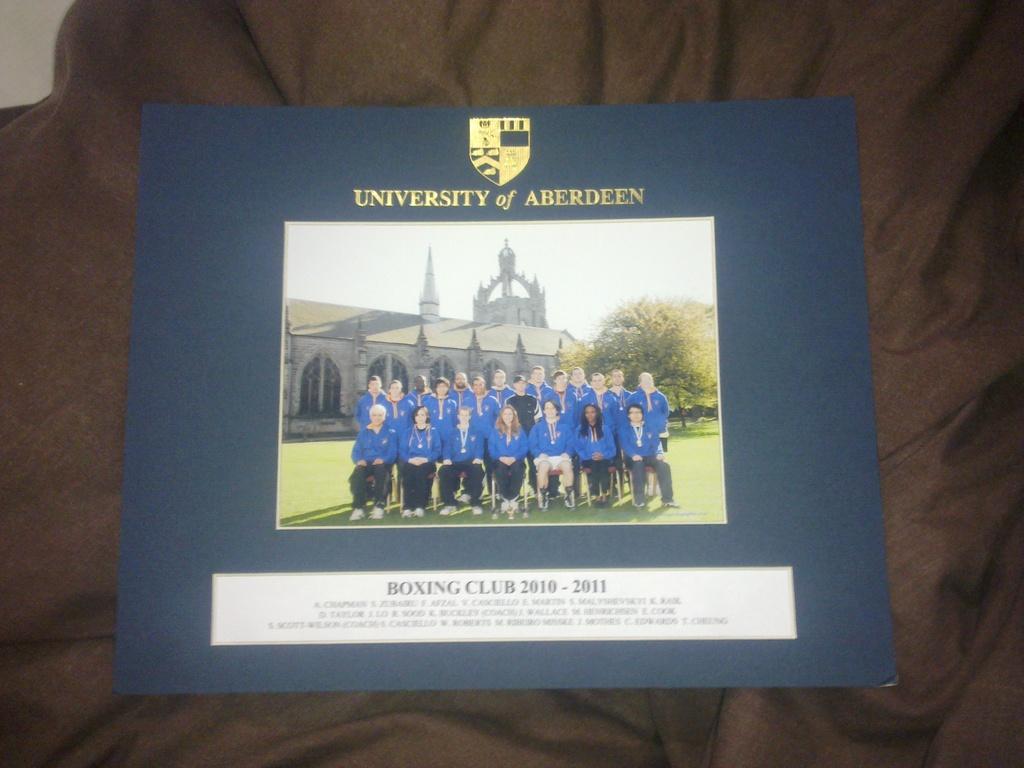What club do they belong to?
Your response must be concise. Boxing club. Is this a picture of the boxing club from the university of aberdeen?
Provide a succinct answer. Yes. 